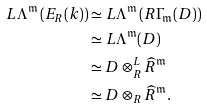<formula> <loc_0><loc_0><loc_500><loc_500>{ L } \Lambda ^ { \mathfrak { m } } \left ( E _ { R } ( k ) \right ) & \simeq { L } \Lambda ^ { \mathfrak { m } } \left ( { R } \Gamma _ { \mathfrak { m } } ( D ) \right ) \\ & \simeq { L } \Lambda ^ { \mathfrak { m } } ( D ) \\ & \simeq D \otimes _ { R } ^ { L } \widehat { R } ^ { \mathfrak { m } } \\ & \simeq D \otimes _ { R } \widehat { R } ^ { \mathfrak { m } } .</formula> 